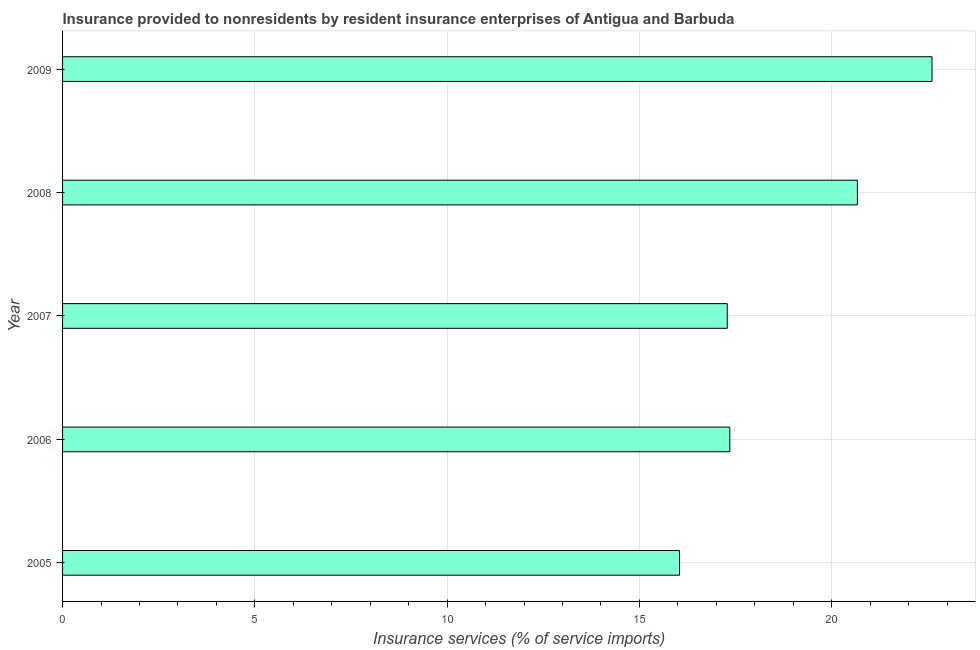Does the graph contain any zero values?
Keep it short and to the point. No. What is the title of the graph?
Offer a very short reply. Insurance provided to nonresidents by resident insurance enterprises of Antigua and Barbuda. What is the label or title of the X-axis?
Offer a very short reply. Insurance services (% of service imports). What is the insurance and financial services in 2005?
Give a very brief answer. 16.04. Across all years, what is the maximum insurance and financial services?
Your answer should be compact. 22.61. Across all years, what is the minimum insurance and financial services?
Ensure brevity in your answer.  16.04. In which year was the insurance and financial services maximum?
Provide a succinct answer. 2009. In which year was the insurance and financial services minimum?
Ensure brevity in your answer.  2005. What is the sum of the insurance and financial services?
Offer a very short reply. 93.96. What is the difference between the insurance and financial services in 2006 and 2008?
Ensure brevity in your answer.  -3.32. What is the average insurance and financial services per year?
Provide a short and direct response. 18.79. What is the median insurance and financial services?
Give a very brief answer. 17.35. Do a majority of the years between 2009 and 2005 (inclusive) have insurance and financial services greater than 22 %?
Ensure brevity in your answer.  Yes. What is the ratio of the insurance and financial services in 2005 to that in 2007?
Provide a short and direct response. 0.93. Is the insurance and financial services in 2007 less than that in 2009?
Ensure brevity in your answer.  Yes. Is the difference between the insurance and financial services in 2005 and 2007 greater than the difference between any two years?
Provide a succinct answer. No. What is the difference between the highest and the second highest insurance and financial services?
Your response must be concise. 1.94. Is the sum of the insurance and financial services in 2006 and 2009 greater than the maximum insurance and financial services across all years?
Offer a very short reply. Yes. What is the difference between the highest and the lowest insurance and financial services?
Offer a very short reply. 6.57. How many bars are there?
Offer a terse response. 5. How many years are there in the graph?
Your response must be concise. 5. What is the difference between two consecutive major ticks on the X-axis?
Your answer should be compact. 5. What is the Insurance services (% of service imports) of 2005?
Your answer should be very brief. 16.04. What is the Insurance services (% of service imports) of 2006?
Your answer should be compact. 17.35. What is the Insurance services (% of service imports) in 2007?
Give a very brief answer. 17.28. What is the Insurance services (% of service imports) in 2008?
Provide a succinct answer. 20.67. What is the Insurance services (% of service imports) in 2009?
Offer a terse response. 22.61. What is the difference between the Insurance services (% of service imports) in 2005 and 2006?
Ensure brevity in your answer.  -1.31. What is the difference between the Insurance services (% of service imports) in 2005 and 2007?
Make the answer very short. -1.24. What is the difference between the Insurance services (% of service imports) in 2005 and 2008?
Your answer should be very brief. -4.62. What is the difference between the Insurance services (% of service imports) in 2005 and 2009?
Your answer should be very brief. -6.57. What is the difference between the Insurance services (% of service imports) in 2006 and 2007?
Provide a short and direct response. 0.07. What is the difference between the Insurance services (% of service imports) in 2006 and 2008?
Your answer should be very brief. -3.32. What is the difference between the Insurance services (% of service imports) in 2006 and 2009?
Make the answer very short. -5.26. What is the difference between the Insurance services (% of service imports) in 2007 and 2008?
Provide a short and direct response. -3.38. What is the difference between the Insurance services (% of service imports) in 2007 and 2009?
Offer a very short reply. -5.33. What is the difference between the Insurance services (% of service imports) in 2008 and 2009?
Make the answer very short. -1.94. What is the ratio of the Insurance services (% of service imports) in 2005 to that in 2006?
Offer a terse response. 0.93. What is the ratio of the Insurance services (% of service imports) in 2005 to that in 2007?
Your answer should be compact. 0.93. What is the ratio of the Insurance services (% of service imports) in 2005 to that in 2008?
Offer a very short reply. 0.78. What is the ratio of the Insurance services (% of service imports) in 2005 to that in 2009?
Your response must be concise. 0.71. What is the ratio of the Insurance services (% of service imports) in 2006 to that in 2007?
Your answer should be compact. 1. What is the ratio of the Insurance services (% of service imports) in 2006 to that in 2008?
Your answer should be very brief. 0.84. What is the ratio of the Insurance services (% of service imports) in 2006 to that in 2009?
Make the answer very short. 0.77. What is the ratio of the Insurance services (% of service imports) in 2007 to that in 2008?
Offer a terse response. 0.84. What is the ratio of the Insurance services (% of service imports) in 2007 to that in 2009?
Keep it short and to the point. 0.76. What is the ratio of the Insurance services (% of service imports) in 2008 to that in 2009?
Provide a succinct answer. 0.91. 